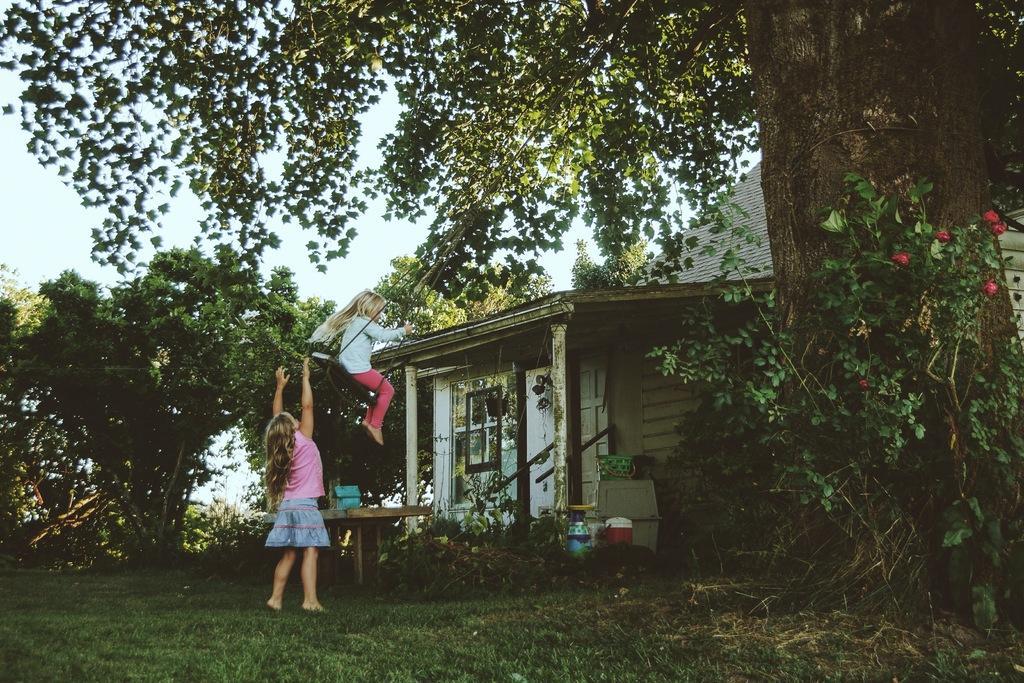Could you give a brief overview of what you see in this image? In this image I can see some grass on the ground, few trees which are green in color, a person standing on the ground, a person on the swing and a house. In the background I can see the sky. 